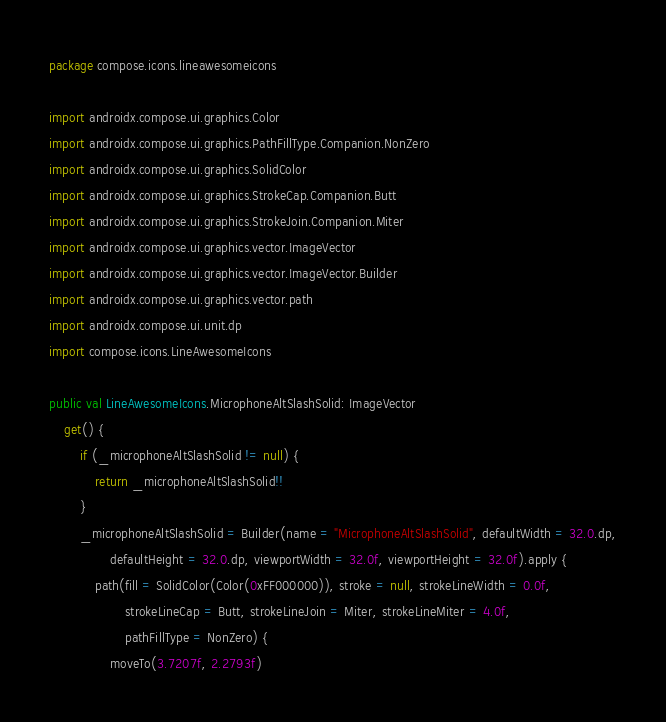Convert code to text. <code><loc_0><loc_0><loc_500><loc_500><_Kotlin_>package compose.icons.lineawesomeicons

import androidx.compose.ui.graphics.Color
import androidx.compose.ui.graphics.PathFillType.Companion.NonZero
import androidx.compose.ui.graphics.SolidColor
import androidx.compose.ui.graphics.StrokeCap.Companion.Butt
import androidx.compose.ui.graphics.StrokeJoin.Companion.Miter
import androidx.compose.ui.graphics.vector.ImageVector
import androidx.compose.ui.graphics.vector.ImageVector.Builder
import androidx.compose.ui.graphics.vector.path
import androidx.compose.ui.unit.dp
import compose.icons.LineAwesomeIcons

public val LineAwesomeIcons.MicrophoneAltSlashSolid: ImageVector
    get() {
        if (_microphoneAltSlashSolid != null) {
            return _microphoneAltSlashSolid!!
        }
        _microphoneAltSlashSolid = Builder(name = "MicrophoneAltSlashSolid", defaultWidth = 32.0.dp,
                defaultHeight = 32.0.dp, viewportWidth = 32.0f, viewportHeight = 32.0f).apply {
            path(fill = SolidColor(Color(0xFF000000)), stroke = null, strokeLineWidth = 0.0f,
                    strokeLineCap = Butt, strokeLineJoin = Miter, strokeLineMiter = 4.0f,
                    pathFillType = NonZero) {
                moveTo(3.7207f, 2.2793f)</code> 